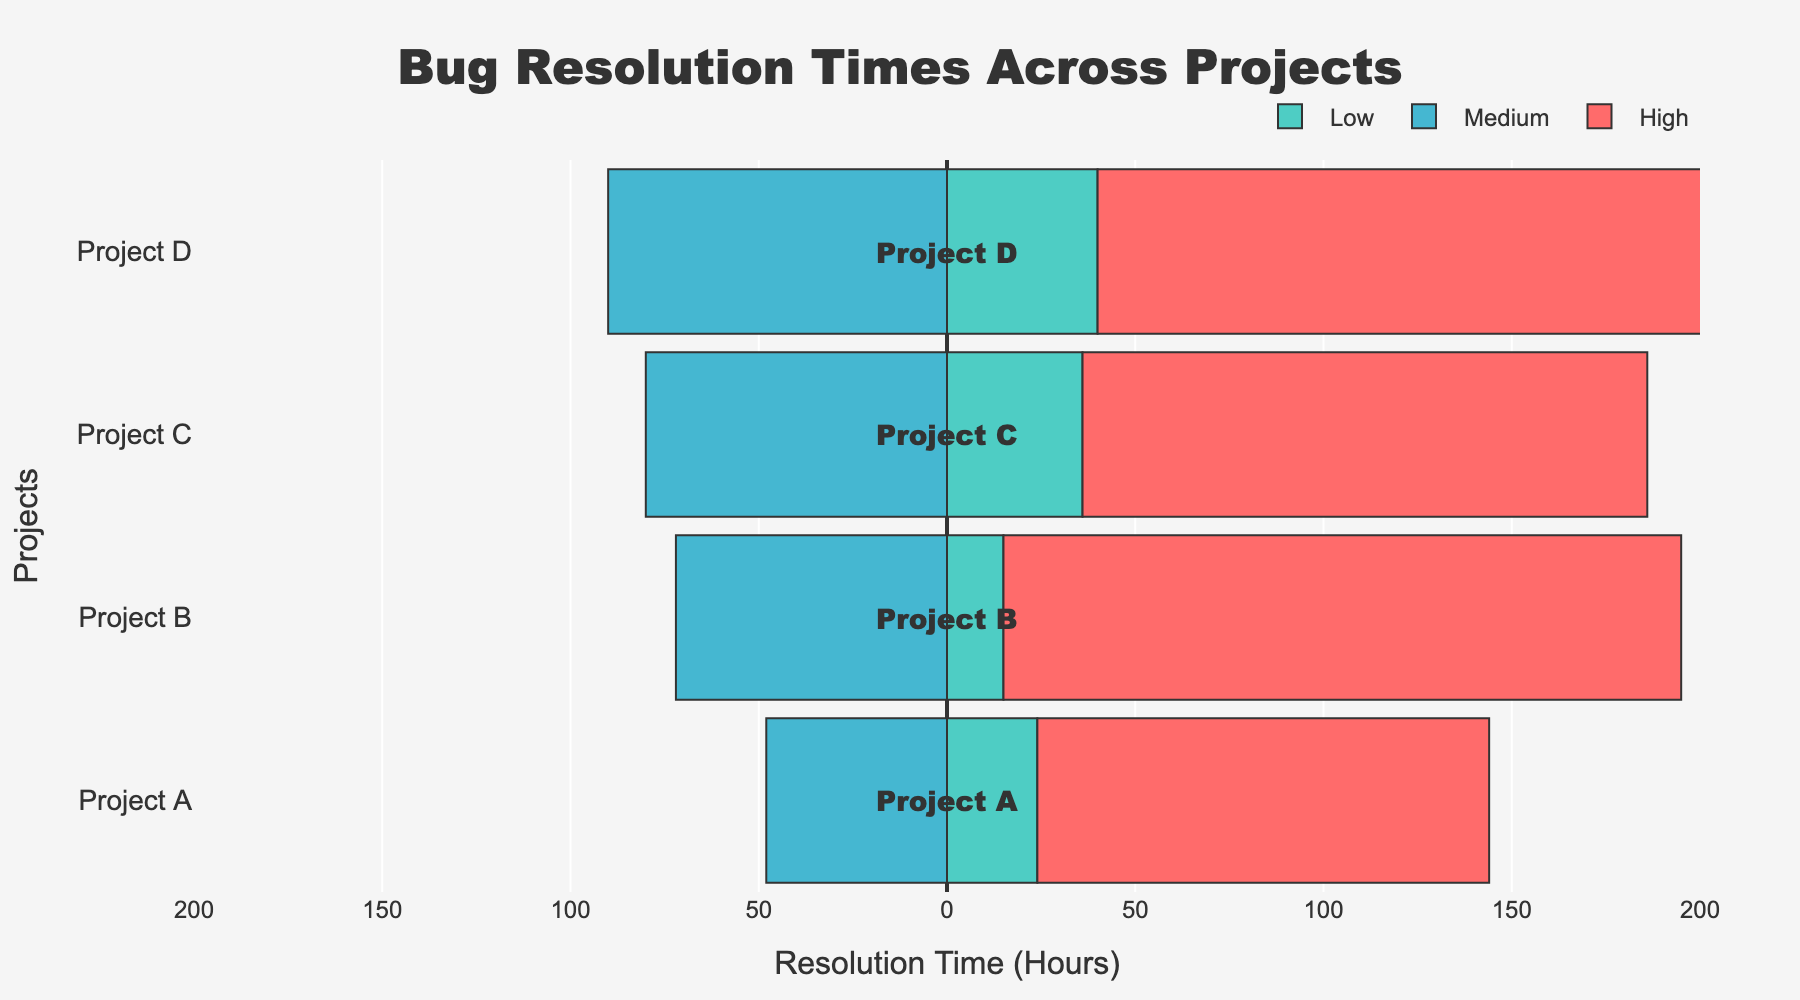What's the project with the highest resolution time for High priority bugs? First, identify the highest resolution times for High priority bugs for each project. Project D has a resolution time of 200 hours, which is the highest among others.
Answer: Project D Which project has the lowest resolution time for Low priority bugs? Compare the resolution times for Low priority bugs across all projects. Project B has the lowest resolution time at 15 hours.
Answer: Project B What is the difference in resolution time for Medium priority bugs between Project A and Project B? Project A has a Medium priority resolution time of 48 hours, and Project B has 72 hours. The difference is 72 - 48 = 24 hours.
Answer: 24 hours How much longer does it take to resolve High priority bugs compared to Low priority bugs in Project C? For Project C, High priority resolution time is 150 hours, and Low priority is 36 hours. The difference is 150 - 36 = 114 hours.
Answer: 114 hours What's the total resolution time for all priority bugs in Project A? Sum the resolution times for Low (24 hours), Medium (48 hours), and High (120 hours) priorities in Project A. The total is 24 + 48 + 120 = 192 hours.
Answer: 192 hours Which priority level has the most vivid/highlighting color in the chart? By examining the chart, the High priority is marked in red, which stands out as the most vivid/highlighting color.
Answer: High If the average resolution time for Medium priority bugs across all projects is increased by 10%, what would it be? First, calculate the average time: (48 + 72 + 80 + 90) / 4 = 72.5 hours. Increasing this by 10%, the new average is 72.5 * 1.1 = 79.75 hours.
Answer: 79.75 hours How does the resolution time for Medium priority bugs in Project D compare to Project C? The resolution time for Medium priority in Project D is 90 hours, while in Project C, it is 80 hours. Project D's resolution time is 10 hours more.
Answer: 10 hours more What is the combined resolution time for High and Low priority bugs in Project B? Project B's High priority resolution time is 180 hours and Low priority is 15 hours. The combined time is 180 + 15 = 195 hours.
Answer: 195 hours 